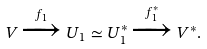<formula> <loc_0><loc_0><loc_500><loc_500>V \xrightarrow { f _ { 1 } } U _ { 1 } \simeq U _ { 1 } ^ { \ast } \xrightarrow { f _ { 1 } ^ { \ast } } V ^ { \ast } .</formula> 